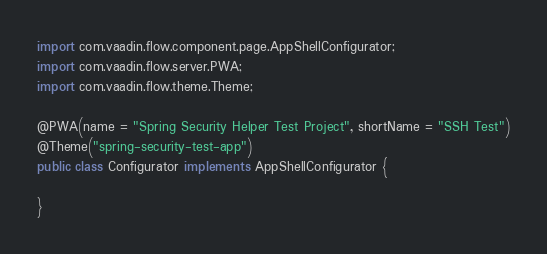Convert code to text. <code><loc_0><loc_0><loc_500><loc_500><_Java_>import com.vaadin.flow.component.page.AppShellConfigurator;
import com.vaadin.flow.server.PWA;
import com.vaadin.flow.theme.Theme;

@PWA(name = "Spring Security Helper Test Project", shortName = "SSH Test")
@Theme("spring-security-test-app")
public class Configurator implements AppShellConfigurator {

}
</code> 